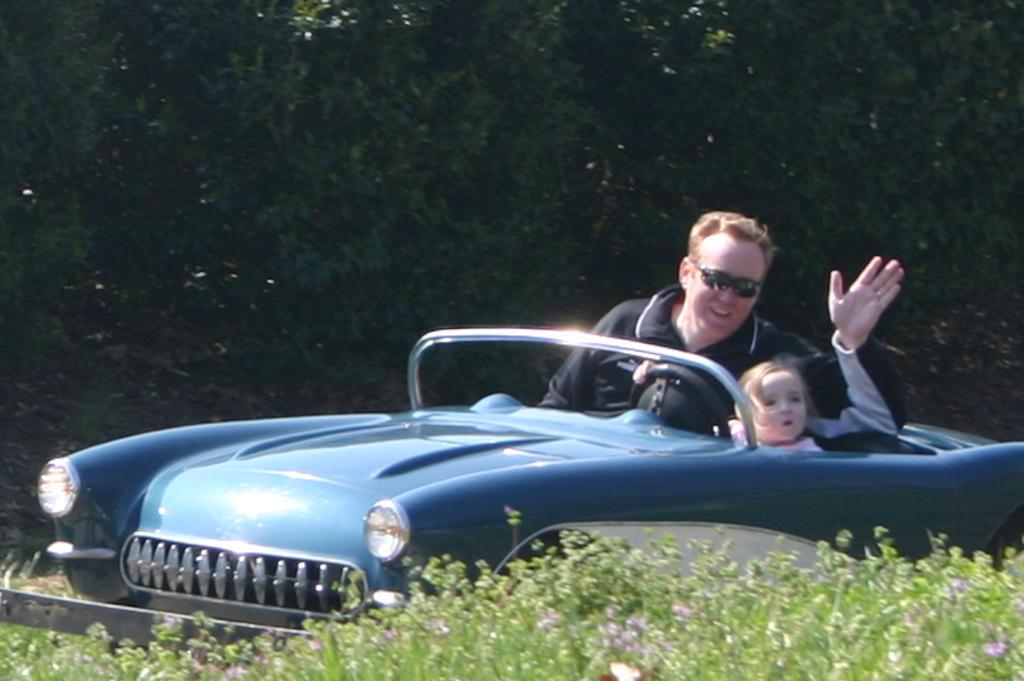What is the man doing in the image? The man is sitting in a car. Who is driving the car in the image? There is a little girl driving the car. What type of servant can be seen attending to the giraffe in the mist in the image? There is no servant, giraffe, or mist present in the image. The image only shows a man sitting in a car and a little girl driving the car. 